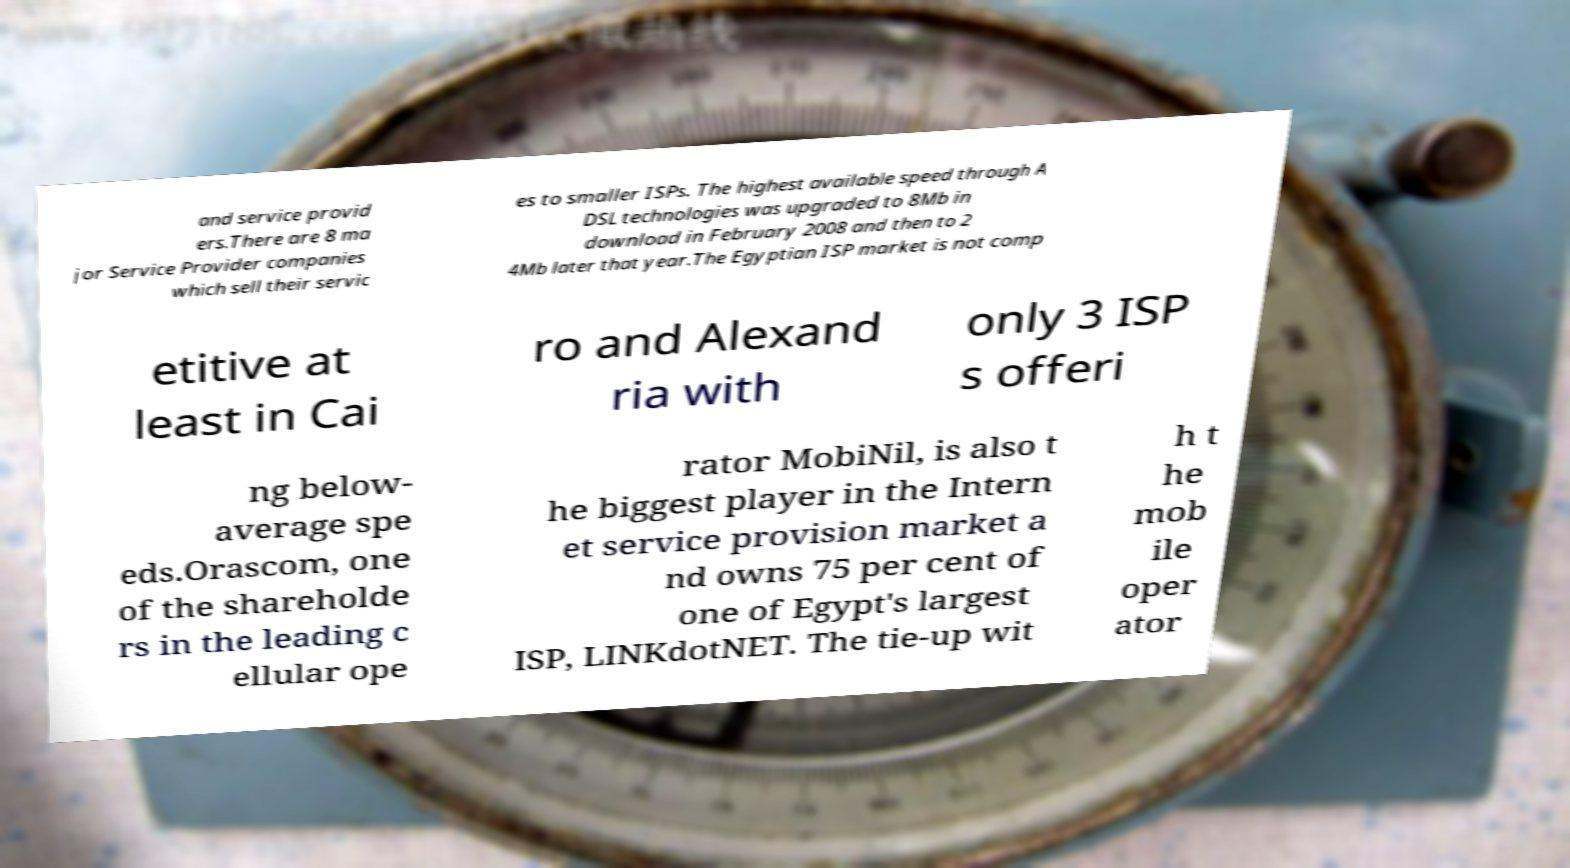Please identify and transcribe the text found in this image. and service provid ers.There are 8 ma jor Service Provider companies which sell their servic es to smaller ISPs. The highest available speed through A DSL technologies was upgraded to 8Mb in download in February 2008 and then to 2 4Mb later that year.The Egyptian ISP market is not comp etitive at least in Cai ro and Alexand ria with only 3 ISP s offeri ng below- average spe eds.Orascom, one of the shareholde rs in the leading c ellular ope rator MobiNil, is also t he biggest player in the Intern et service provision market a nd owns 75 per cent of one of Egypt's largest ISP, LINKdotNET. The tie-up wit h t he mob ile oper ator 